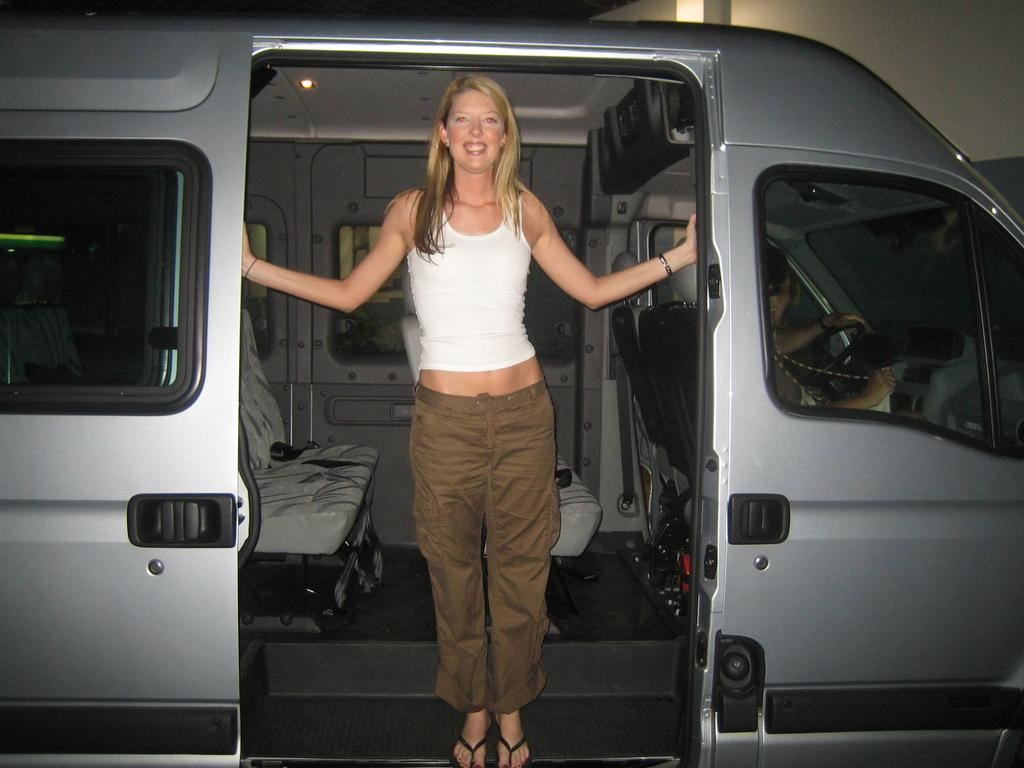Who is present in the image? There is a woman in the image. What is the woman wearing? The woman is wearing a white vest and brown pants. Where is the woman located in the image? The woman is standing in a car. Who else is in the car? There is a person sitting in the driver's seat of the car. What value does the woman request from the driver in the image? There is no indication in the image that the woman is requesting any value from the driver. 